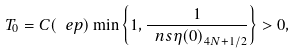<formula> <loc_0><loc_0><loc_500><loc_500>T _ { 0 } = C ( \ e p ) \min \left \{ 1 , \frac { 1 } { \ n s { \eta ( 0 ) } _ { 4 N + 1 / 2 } } \right \} > 0 ,</formula> 